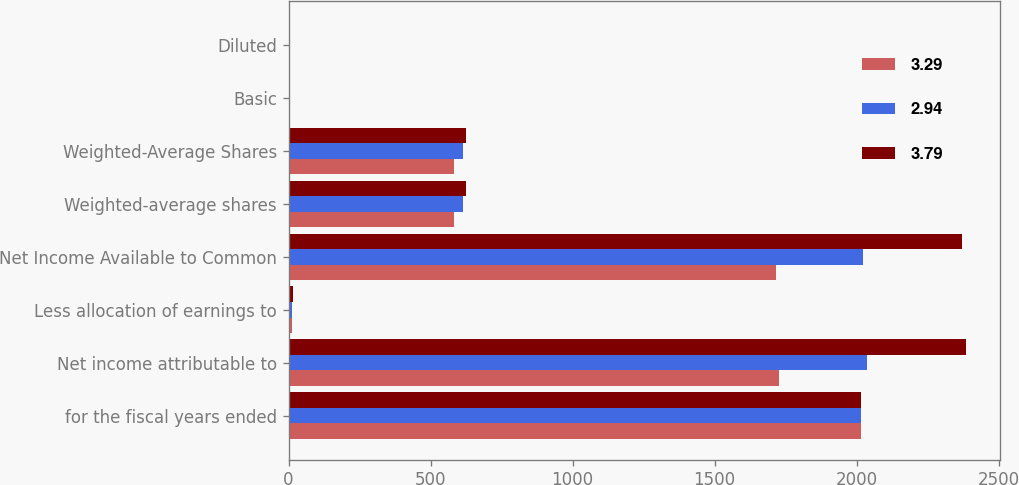Convert chart to OTSL. <chart><loc_0><loc_0><loc_500><loc_500><stacked_bar_chart><ecel><fcel>for the fiscal years ended<fcel>Net income attributable to<fcel>Less allocation of earnings to<fcel>Net Income Available to Common<fcel>Weighted-average shares<fcel>Weighted-Average Shares<fcel>Basic<fcel>Diluted<nl><fcel>3.29<fcel>2016<fcel>1726.7<fcel>10.9<fcel>1715.8<fcel>583.8<fcel>583.8<fcel>2.94<fcel>2.94<nl><fcel>2.94<fcel>2015<fcel>2035.3<fcel>12<fcel>2023.3<fcel>614.8<fcel>614.9<fcel>3.29<fcel>3.29<nl><fcel>3.79<fcel>2014<fcel>2384.3<fcel>14.3<fcel>2370<fcel>624.8<fcel>625.2<fcel>3.79<fcel>3.79<nl></chart> 